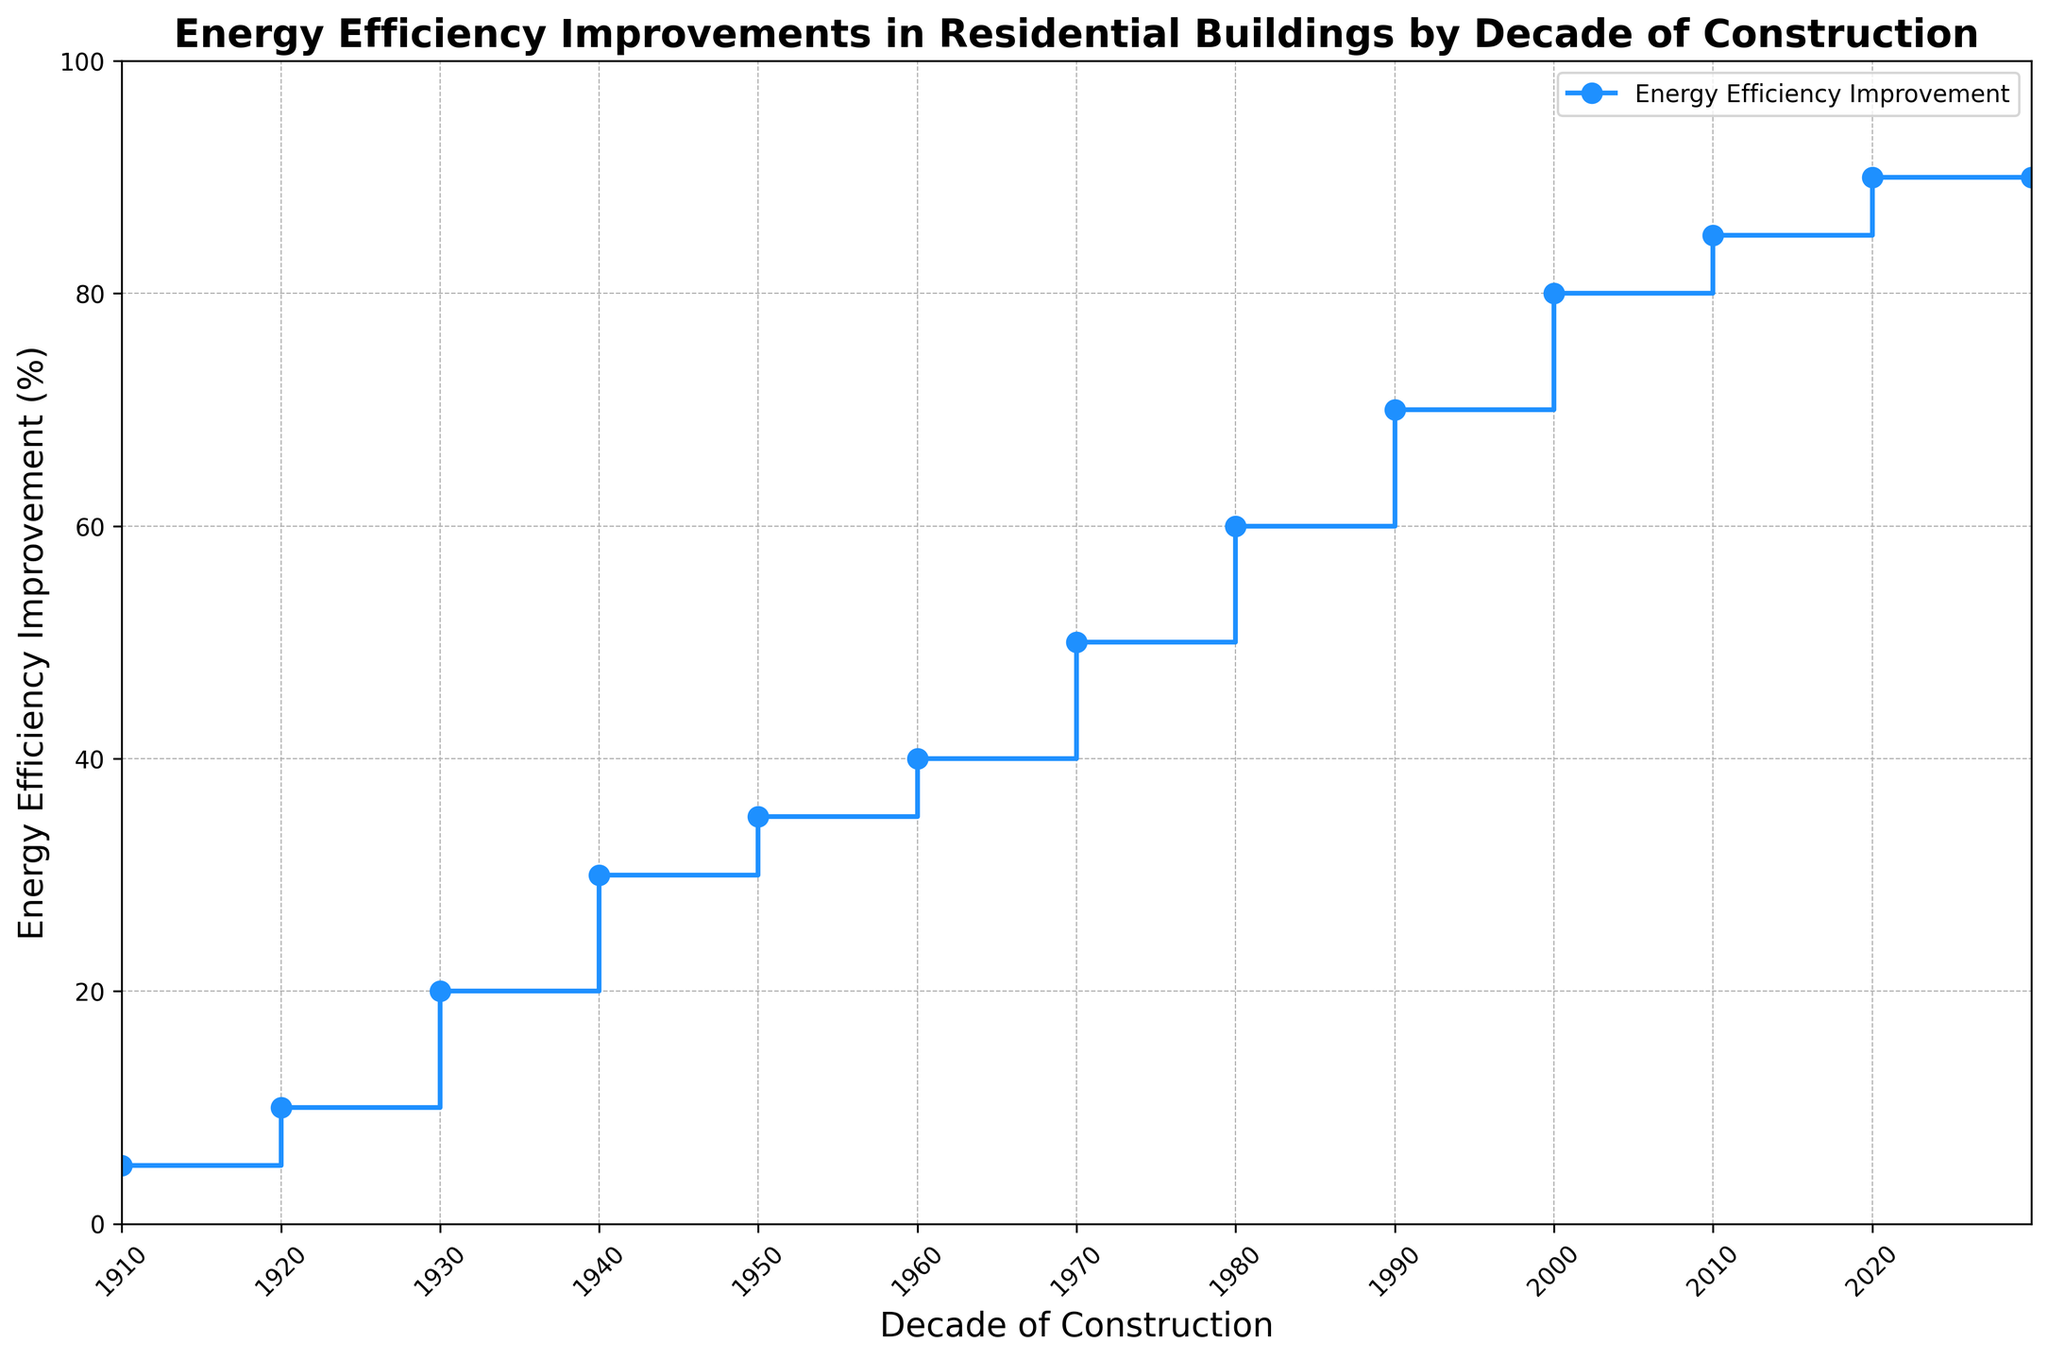What was the energy efficiency improvement percentage for buildings constructed between 1970-1979? According to the staircase plot, the value corresponding to the 1970-1979 interval is read directly from the y-axis.
Answer: 50% Which decade experienced the highest energy efficiency improvement? By examining the maximum point on the y-axis, the highest percentage improvement is seen in the 2020-2029 interval.
Answer: 2020-2029 How does the energy efficiency improvement percentage for buildings constructed in the 1920s compare to those constructed in the 1980s? From the plot, the efficiency percentage for the 1920s is 10%, and for the 1980s, it is 60%, showing a 50% increase.
Answer: 50% higher in the 1980s Calculate the average energy efficiency improvement percentage for buildings constructed between 1910 and 1949. Add the percentages for the decades 1910-1919 (5%), 1920-1929 (10%), 1930-1939 (20%), and 1940-1949 (30%) and divide by 4. (5 + 10 + 20 + 30) / 4 = 65 / 4 = 16.25%
Answer: 16.25% What was the change in energy efficiency improvement percentage between the 1950s and 1960s? Subtract the percentage for the 1950s (35%) from the percentage for the 1960s (40%). 40% - 35% = 5%
Answer: 5% Identify the period showing the largest increase in energy efficiency improvement compared to its previous decade. By examining the differences between consecutive decades, the largest increase is between the 1960s (40%) and 1970s (50%), which is 10%.
Answer: 1960s to 1970s What is the median energy efficiency improvement percentage over the given periods? List the percentages in order (5%, 10%, 20%, 30%, 35%, 40%, 50%, 60%, 70%, 80%, 85%, 90%), the median is the average of the 6th and 7th (40% and 50%). (40 + 50) / 2 = 45%
Answer: 45% By how much did the energy efficiency improvement percentage increase from the earliest to the latest decade? Subtract the earliest percentage (5% for 1910-1919) from the latest percentage (90% for 2020-2029). 90% - 5% = 85%
Answer: 85% What percentage improvement is expected for buildings constructed in the 2010s? Read directly from the plot for the 2010-2019 period.
Answer: 85% Which decade saw an energy efficiency improvement percentage of 35%? Examine the y-axis labels to find that the 1950-1959 period corresponds to 35%.
Answer: 1950-1959 